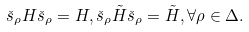<formula> <loc_0><loc_0><loc_500><loc_500>\check { s } _ { \rho } H \check { s } _ { \rho } = H , \check { s } _ { \rho } \tilde { H } \check { s } _ { \rho } = \tilde { H } , \forall \rho \in \Delta .</formula> 